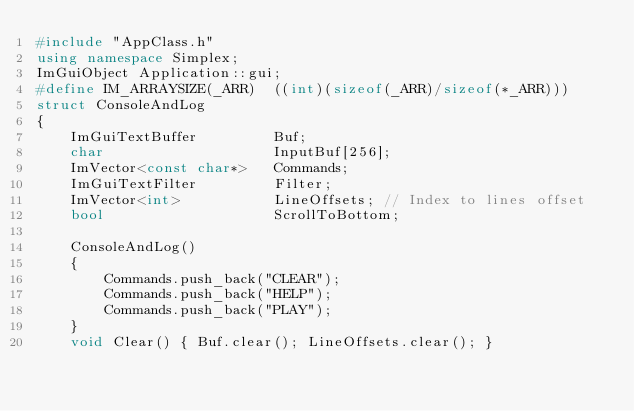<code> <loc_0><loc_0><loc_500><loc_500><_C++_>#include "AppClass.h"
using namespace Simplex;
ImGuiObject Application::gui;
#define IM_ARRAYSIZE(_ARR)  ((int)(sizeof(_ARR)/sizeof(*_ARR)))
struct ConsoleAndLog
{
	ImGuiTextBuffer			Buf;
	char					InputBuf[256];
	ImVector<const char*>	Commands;
	ImGuiTextFilter			Filter;
	ImVector<int>			LineOffsets; // Index to lines offset
	bool					ScrollToBottom;

	ConsoleAndLog()
	{
		Commands.push_back("CLEAR");
		Commands.push_back("HELP");
		Commands.push_back("PLAY");
	}
	void Clear() { Buf.clear(); LineOffsets.clear(); }</code> 